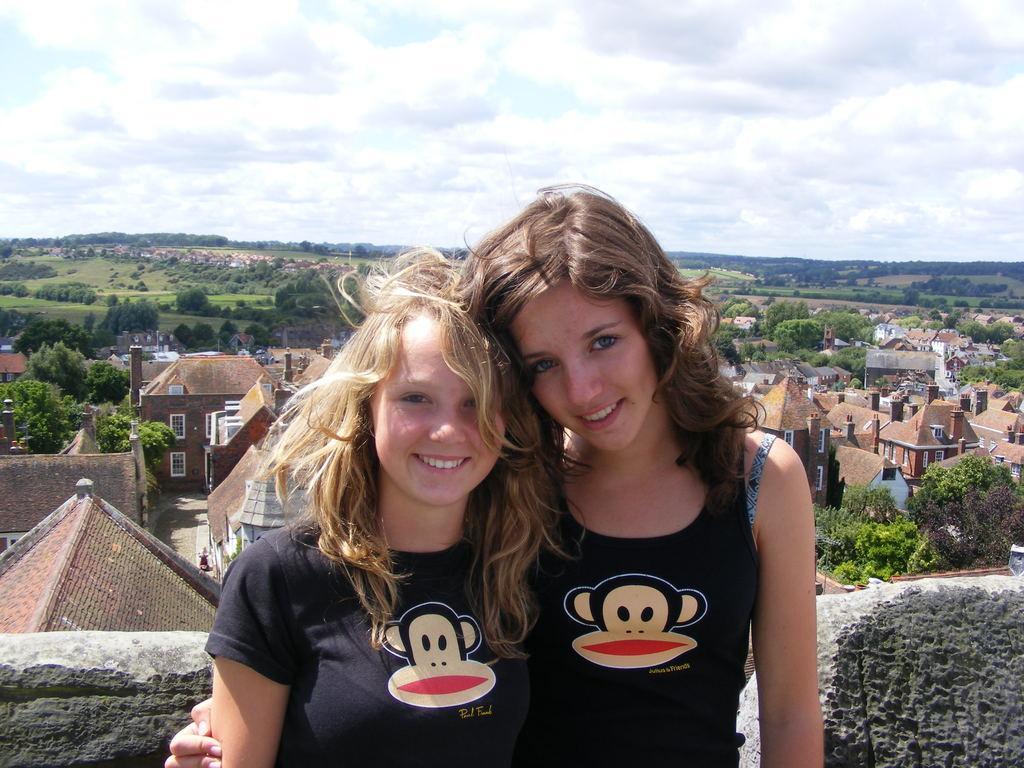Describe this image in one or two sentences. This is an outside view. Here I can see two women wearing t-shirts, smiling and giving pose for the picture. At the back of these people I can see a wall. In the background there are many buildings and trees. At the top of the image I can see the sky and clouds. 